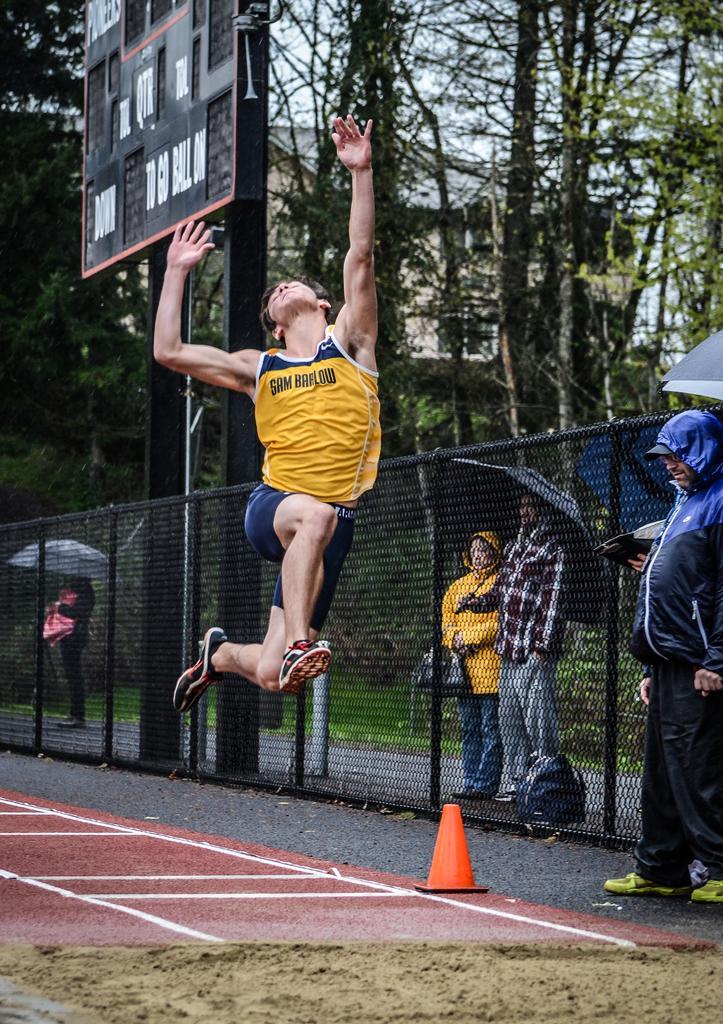Please provide a concise description of this image. In the center of the image there is a person jumping in the air. At the bottom of the image there is a mat. There is a traffic cone cup. There is sand. On the right side of the image there is a metal fence. There are people standing on the road and they are holding umbrellas. In the background of the image There is a board. There are trees. There is a building and sky. 